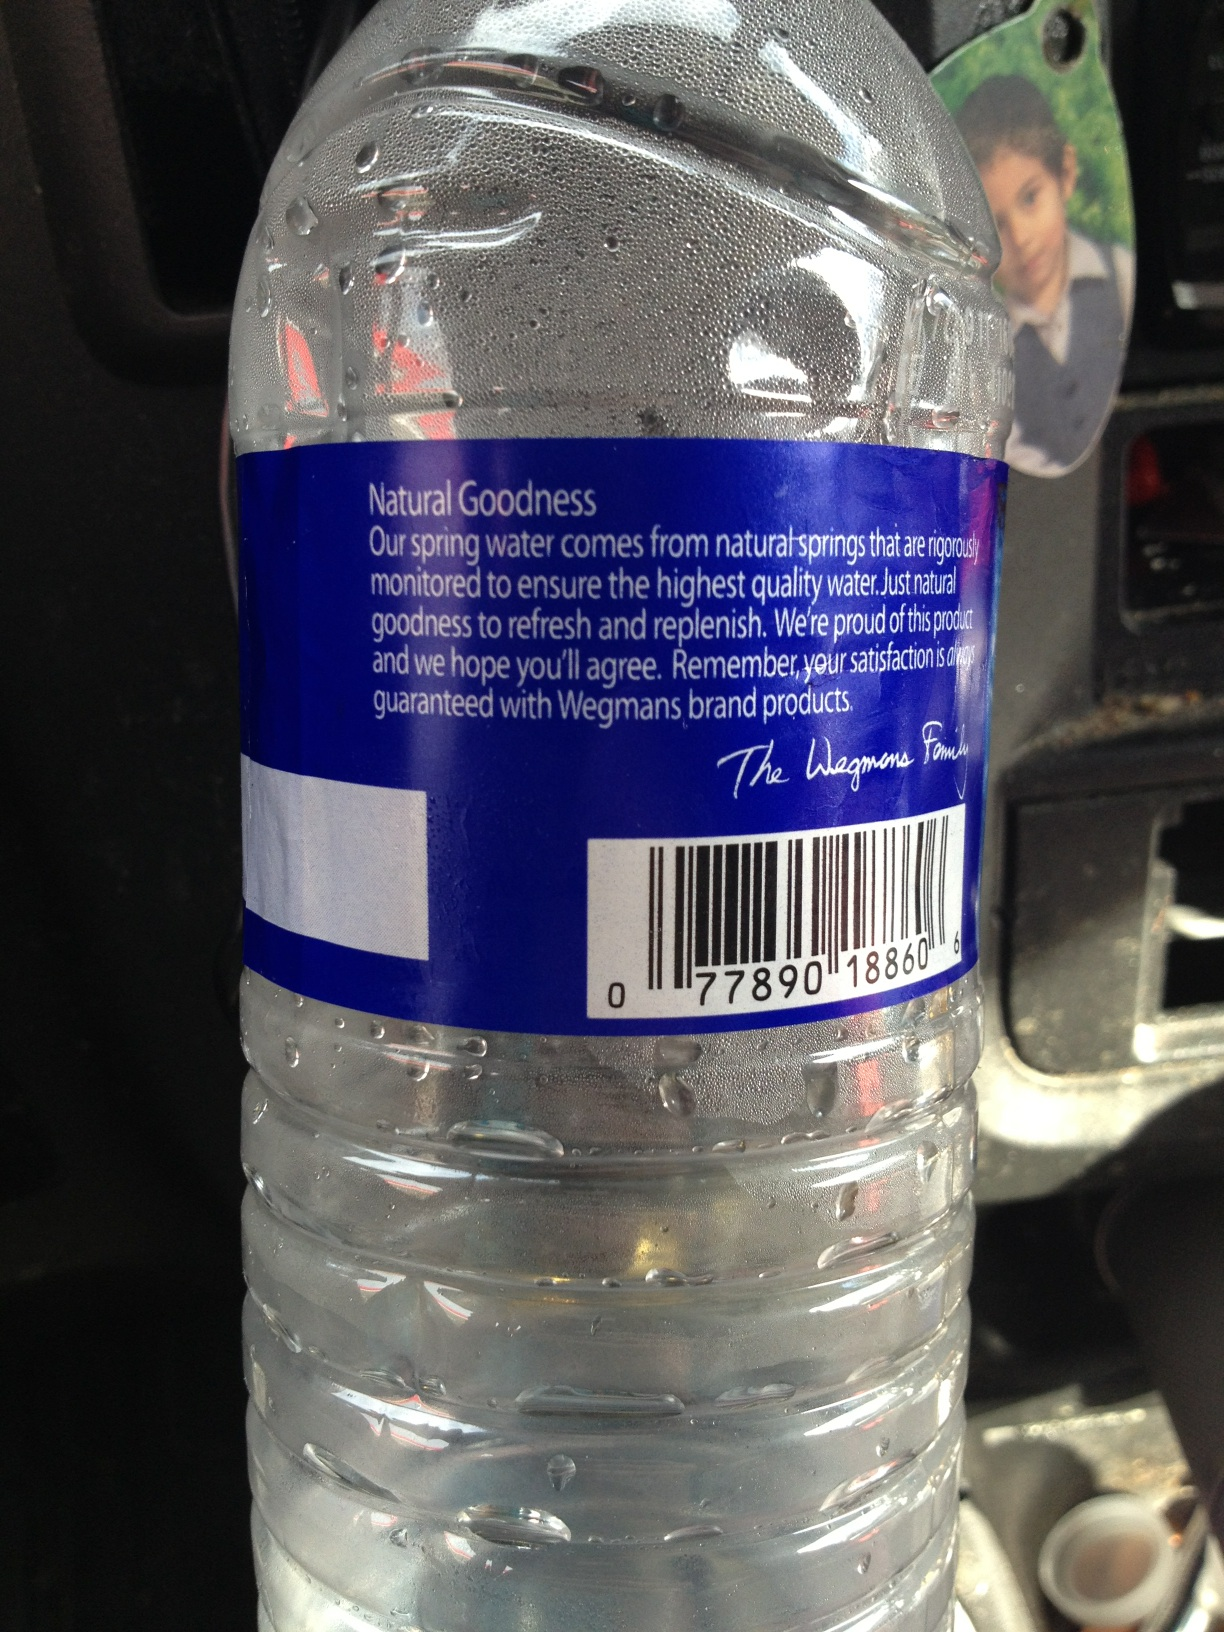Invent a wild and creative use for a water bottle like this that's out of the ordinary. Imagine if this water bottle had a hidden compartment inside. You twist the bottom and out pops a tiny, foldable cup! Perfect for sharing a drink with a friend on the go. It could also have a tiny LED light that turns on when you shake the bottle, making it a multi-purpose flashlight and hydration accessory. Great for camping trips and nighttime adventures! 